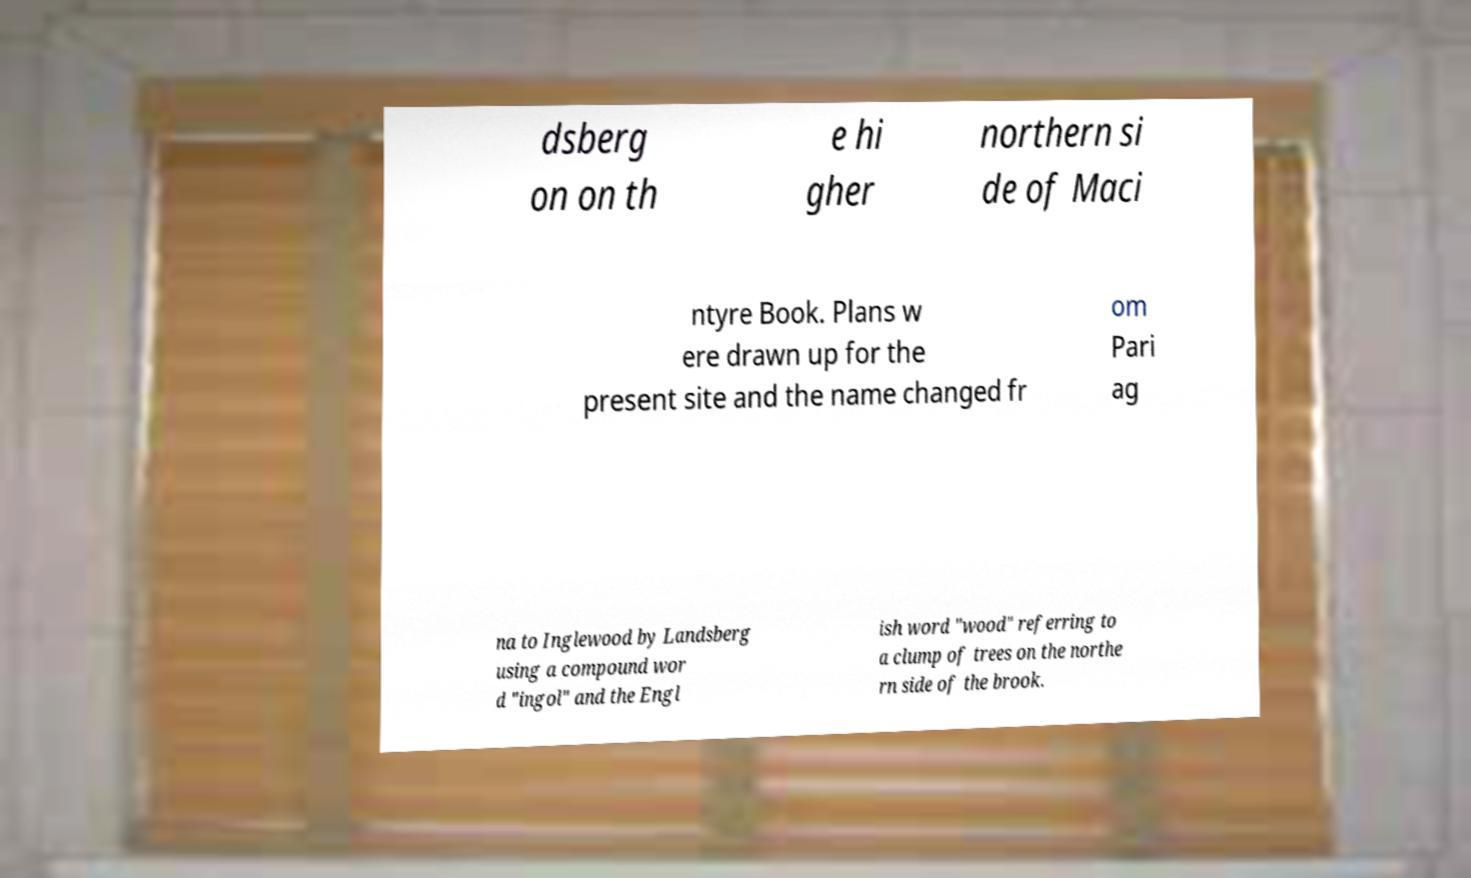There's text embedded in this image that I need extracted. Can you transcribe it verbatim? dsberg on on th e hi gher northern si de of Maci ntyre Book. Plans w ere drawn up for the present site and the name changed fr om Pari ag na to Inglewood by Landsberg using a compound wor d "ingol" and the Engl ish word "wood" referring to a clump of trees on the northe rn side of the brook. 